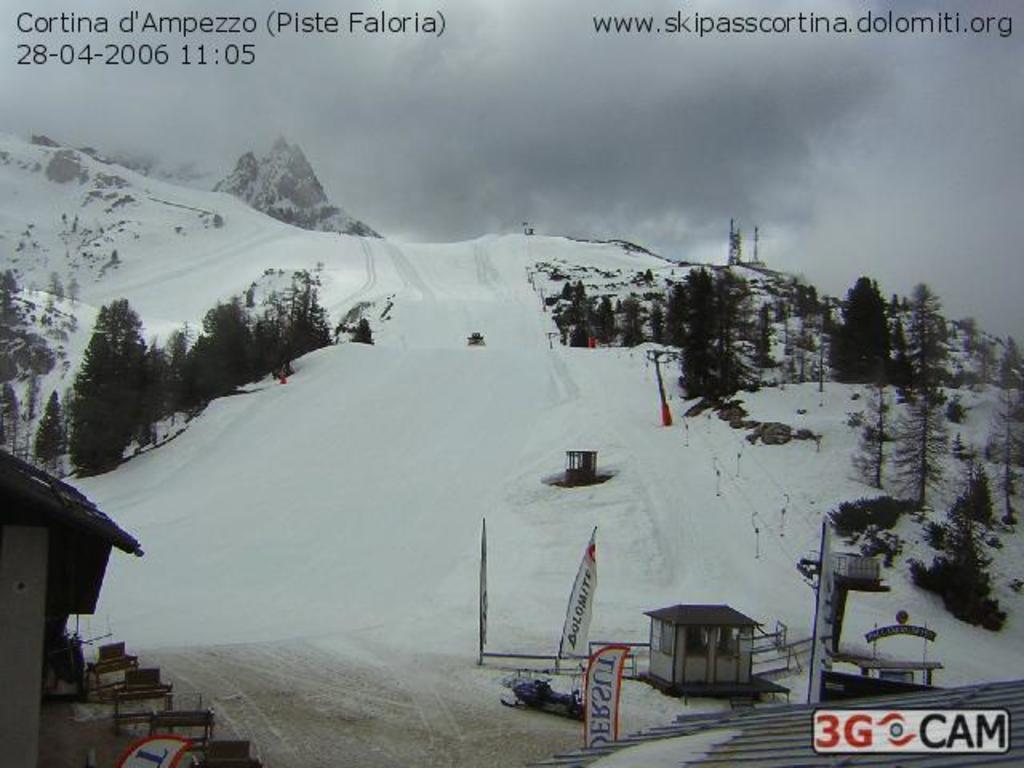In one or two sentences, can you explain what this image depicts? There is snow. On the sides there are trees. Also there are poles. On the right side there is a room. Also there are banners. On the left side there is a house. Near to that there are some objects. In the right bottom corner there is a watermark. At the top something is written on the image. 